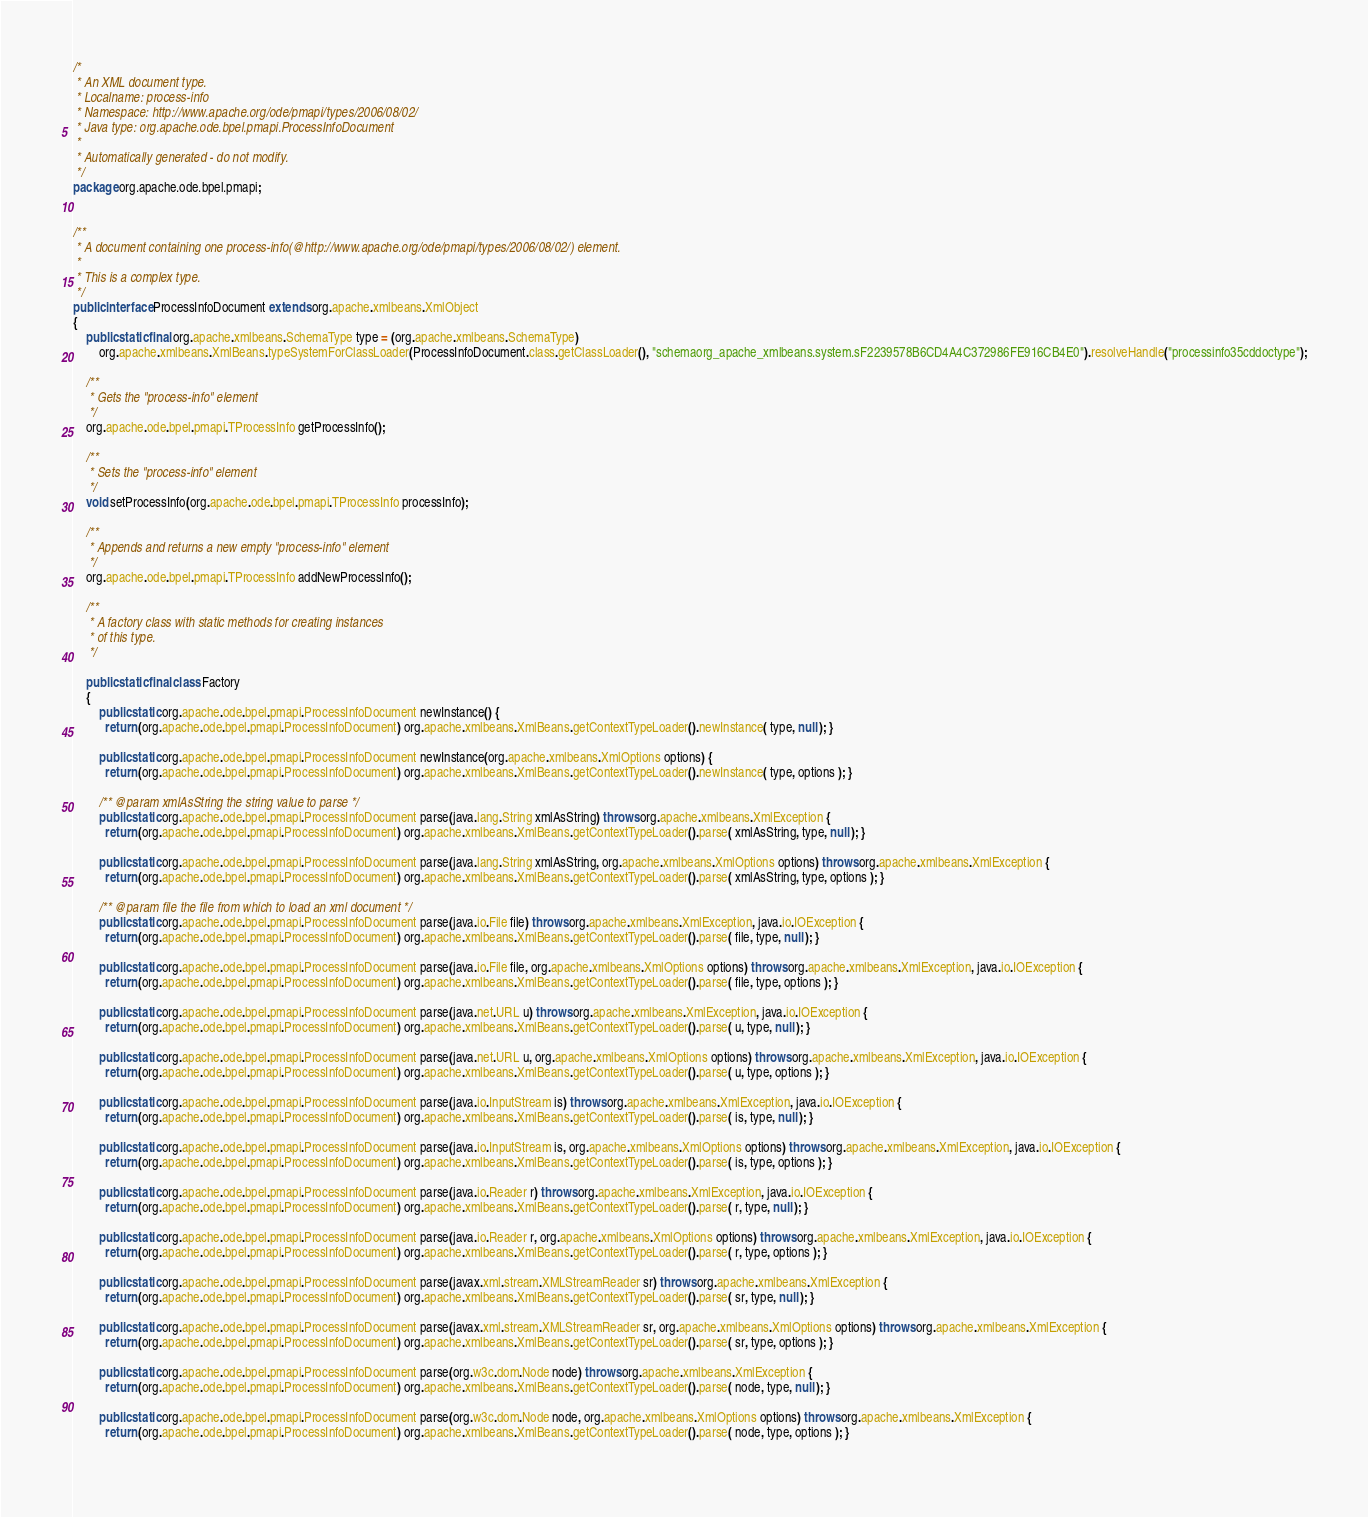<code> <loc_0><loc_0><loc_500><loc_500><_Java_>/*
 * An XML document type.
 * Localname: process-info
 * Namespace: http://www.apache.org/ode/pmapi/types/2006/08/02/
 * Java type: org.apache.ode.bpel.pmapi.ProcessInfoDocument
 *
 * Automatically generated - do not modify.
 */
package org.apache.ode.bpel.pmapi;


/**
 * A document containing one process-info(@http://www.apache.org/ode/pmapi/types/2006/08/02/) element.
 *
 * This is a complex type.
 */
public interface ProcessInfoDocument extends org.apache.xmlbeans.XmlObject
{
    public static final org.apache.xmlbeans.SchemaType type = (org.apache.xmlbeans.SchemaType)
        org.apache.xmlbeans.XmlBeans.typeSystemForClassLoader(ProcessInfoDocument.class.getClassLoader(), "schemaorg_apache_xmlbeans.system.sF2239578B6CD4A4C372986FE916CB4E0").resolveHandle("processinfo35cddoctype");
    
    /**
     * Gets the "process-info" element
     */
    org.apache.ode.bpel.pmapi.TProcessInfo getProcessInfo();
    
    /**
     * Sets the "process-info" element
     */
    void setProcessInfo(org.apache.ode.bpel.pmapi.TProcessInfo processInfo);
    
    /**
     * Appends and returns a new empty "process-info" element
     */
    org.apache.ode.bpel.pmapi.TProcessInfo addNewProcessInfo();
    
    /**
     * A factory class with static methods for creating instances
     * of this type.
     */
    
    public static final class Factory
    {
        public static org.apache.ode.bpel.pmapi.ProcessInfoDocument newInstance() {
          return (org.apache.ode.bpel.pmapi.ProcessInfoDocument) org.apache.xmlbeans.XmlBeans.getContextTypeLoader().newInstance( type, null ); }
        
        public static org.apache.ode.bpel.pmapi.ProcessInfoDocument newInstance(org.apache.xmlbeans.XmlOptions options) {
          return (org.apache.ode.bpel.pmapi.ProcessInfoDocument) org.apache.xmlbeans.XmlBeans.getContextTypeLoader().newInstance( type, options ); }
        
        /** @param xmlAsString the string value to parse */
        public static org.apache.ode.bpel.pmapi.ProcessInfoDocument parse(java.lang.String xmlAsString) throws org.apache.xmlbeans.XmlException {
          return (org.apache.ode.bpel.pmapi.ProcessInfoDocument) org.apache.xmlbeans.XmlBeans.getContextTypeLoader().parse( xmlAsString, type, null ); }
        
        public static org.apache.ode.bpel.pmapi.ProcessInfoDocument parse(java.lang.String xmlAsString, org.apache.xmlbeans.XmlOptions options) throws org.apache.xmlbeans.XmlException {
          return (org.apache.ode.bpel.pmapi.ProcessInfoDocument) org.apache.xmlbeans.XmlBeans.getContextTypeLoader().parse( xmlAsString, type, options ); }
        
        /** @param file the file from which to load an xml document */
        public static org.apache.ode.bpel.pmapi.ProcessInfoDocument parse(java.io.File file) throws org.apache.xmlbeans.XmlException, java.io.IOException {
          return (org.apache.ode.bpel.pmapi.ProcessInfoDocument) org.apache.xmlbeans.XmlBeans.getContextTypeLoader().parse( file, type, null ); }
        
        public static org.apache.ode.bpel.pmapi.ProcessInfoDocument parse(java.io.File file, org.apache.xmlbeans.XmlOptions options) throws org.apache.xmlbeans.XmlException, java.io.IOException {
          return (org.apache.ode.bpel.pmapi.ProcessInfoDocument) org.apache.xmlbeans.XmlBeans.getContextTypeLoader().parse( file, type, options ); }
        
        public static org.apache.ode.bpel.pmapi.ProcessInfoDocument parse(java.net.URL u) throws org.apache.xmlbeans.XmlException, java.io.IOException {
          return (org.apache.ode.bpel.pmapi.ProcessInfoDocument) org.apache.xmlbeans.XmlBeans.getContextTypeLoader().parse( u, type, null ); }
        
        public static org.apache.ode.bpel.pmapi.ProcessInfoDocument parse(java.net.URL u, org.apache.xmlbeans.XmlOptions options) throws org.apache.xmlbeans.XmlException, java.io.IOException {
          return (org.apache.ode.bpel.pmapi.ProcessInfoDocument) org.apache.xmlbeans.XmlBeans.getContextTypeLoader().parse( u, type, options ); }
        
        public static org.apache.ode.bpel.pmapi.ProcessInfoDocument parse(java.io.InputStream is) throws org.apache.xmlbeans.XmlException, java.io.IOException {
          return (org.apache.ode.bpel.pmapi.ProcessInfoDocument) org.apache.xmlbeans.XmlBeans.getContextTypeLoader().parse( is, type, null ); }
        
        public static org.apache.ode.bpel.pmapi.ProcessInfoDocument parse(java.io.InputStream is, org.apache.xmlbeans.XmlOptions options) throws org.apache.xmlbeans.XmlException, java.io.IOException {
          return (org.apache.ode.bpel.pmapi.ProcessInfoDocument) org.apache.xmlbeans.XmlBeans.getContextTypeLoader().parse( is, type, options ); }
        
        public static org.apache.ode.bpel.pmapi.ProcessInfoDocument parse(java.io.Reader r) throws org.apache.xmlbeans.XmlException, java.io.IOException {
          return (org.apache.ode.bpel.pmapi.ProcessInfoDocument) org.apache.xmlbeans.XmlBeans.getContextTypeLoader().parse( r, type, null ); }
        
        public static org.apache.ode.bpel.pmapi.ProcessInfoDocument parse(java.io.Reader r, org.apache.xmlbeans.XmlOptions options) throws org.apache.xmlbeans.XmlException, java.io.IOException {
          return (org.apache.ode.bpel.pmapi.ProcessInfoDocument) org.apache.xmlbeans.XmlBeans.getContextTypeLoader().parse( r, type, options ); }
        
        public static org.apache.ode.bpel.pmapi.ProcessInfoDocument parse(javax.xml.stream.XMLStreamReader sr) throws org.apache.xmlbeans.XmlException {
          return (org.apache.ode.bpel.pmapi.ProcessInfoDocument) org.apache.xmlbeans.XmlBeans.getContextTypeLoader().parse( sr, type, null ); }
        
        public static org.apache.ode.bpel.pmapi.ProcessInfoDocument parse(javax.xml.stream.XMLStreamReader sr, org.apache.xmlbeans.XmlOptions options) throws org.apache.xmlbeans.XmlException {
          return (org.apache.ode.bpel.pmapi.ProcessInfoDocument) org.apache.xmlbeans.XmlBeans.getContextTypeLoader().parse( sr, type, options ); }
        
        public static org.apache.ode.bpel.pmapi.ProcessInfoDocument parse(org.w3c.dom.Node node) throws org.apache.xmlbeans.XmlException {
          return (org.apache.ode.bpel.pmapi.ProcessInfoDocument) org.apache.xmlbeans.XmlBeans.getContextTypeLoader().parse( node, type, null ); }
        
        public static org.apache.ode.bpel.pmapi.ProcessInfoDocument parse(org.w3c.dom.Node node, org.apache.xmlbeans.XmlOptions options) throws org.apache.xmlbeans.XmlException {
          return (org.apache.ode.bpel.pmapi.ProcessInfoDocument) org.apache.xmlbeans.XmlBeans.getContextTypeLoader().parse( node, type, options ); }
        </code> 